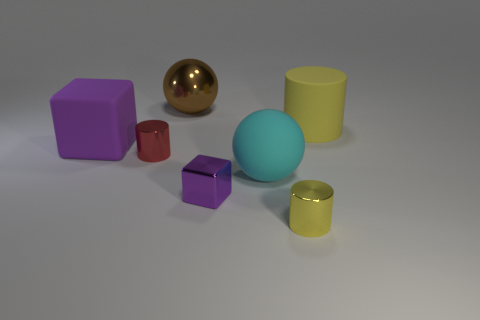There is a cylinder on the left side of the cyan sphere; does it have the same color as the cylinder on the right side of the small yellow cylinder? No, the colors are different. The cylinder to the left of the cyan sphere has a deep olive green hue, while the cylinder to the right of the small yellow cylinder is gold. 